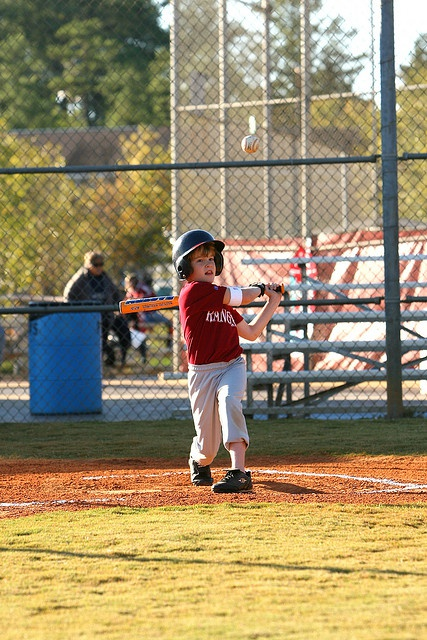Describe the objects in this image and their specific colors. I can see people in olive, maroon, gray, black, and white tones, people in olive, black, gray, beige, and maroon tones, baseball bat in olive, red, navy, brown, and black tones, people in olive, salmon, black, brown, and gray tones, and sports ball in olive, darkgray, ivory, tan, and gray tones in this image. 